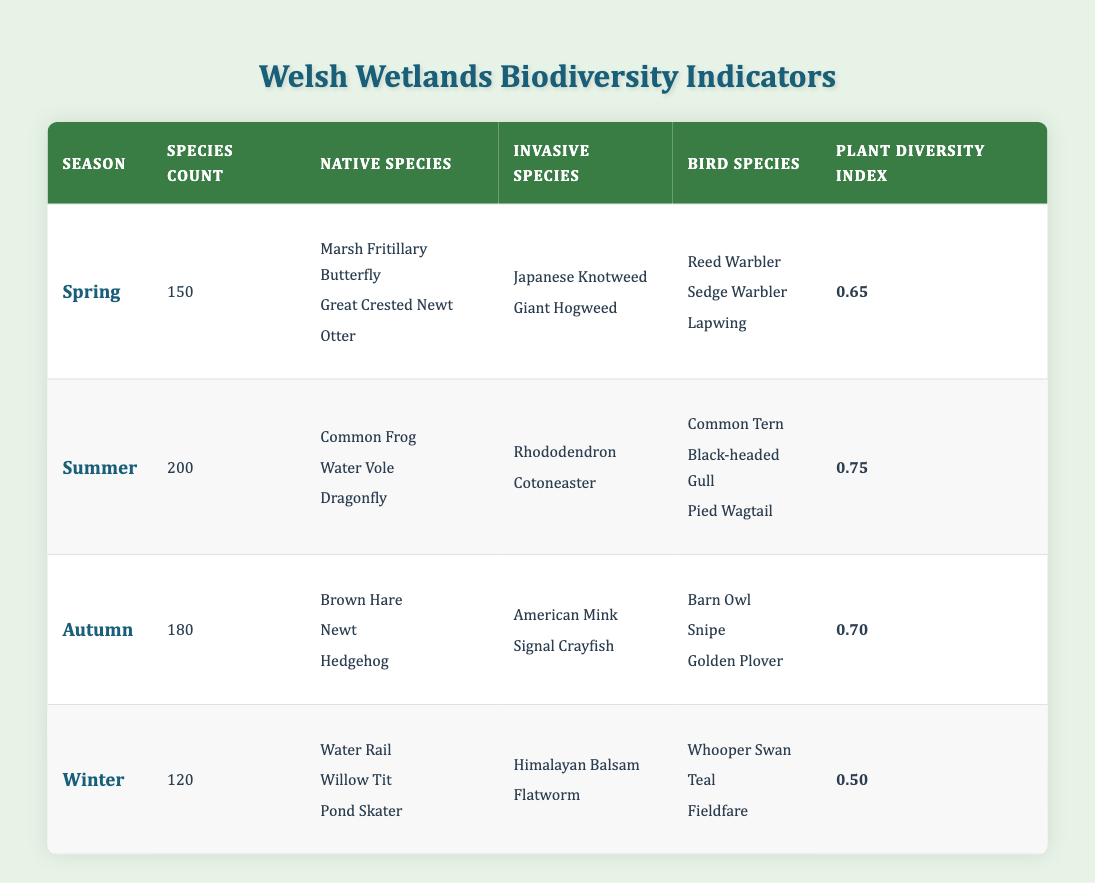What is the species count in Summer? The table directly states the species count for Summer is 200.
Answer: 200 Which Native Species are found in Autumn? The table lists three native species in Autumn: Brown Hare, Newt, and Hedgehog.
Answer: Brown Hare, Newt, Hedgehog Is the Plant Diversity Index higher in Spring or Winter? The Plant Diversity Index for Spring is 0.65, while for Winter, it is 0.50. Since 0.65 is greater than 0.50, it is higher in Spring.
Answer: Yes What is the total number of Species Count across all seasons? To find the total species count, we sum the counts for each season: 150 (Spring) + 200 (Summer) + 180 (Autumn) + 120 (Winter) = 650.
Answer: 650 How many Invasive Species are there in Winter? The table shows that in Winter, there are two invasive species: Himalayan Balsam and Flatworm.
Answer: 2 What is the average Plant Diversity Index for all seasons? The Plant Diversity Index values are 0.65 (Spring), 0.75 (Summer), 0.70 (Autumn), and 0.50 (Winter). To calculate the average, sum these values: 0.65 + 0.75 + 0.70 + 0.50 = 2.60, and divide by the number of seasons (4): 2.60 / 4 = 0.65.
Answer: 0.65 Which season has the highest number of Bird Species? The table lists the number of bird species for each season: Spring has 3, Summer has 3, Autumn has 3, and Winter has 3. All seasons have the same number of bird species, which is 3.
Answer: No Are there any invasive species in Spring? The table indicates that Spring has invasive species: Japanese Knotweed and Giant Hogweed. Therefore, there are invasive species in Spring.
Answer: Yes Which Native Species appears in both Spring and Summer? From the lists of native species, there is no overlap between the native species in Spring (Marsh Fritillary Butterfly, Great Crested Newt, Otter) and Summer (Common Frog, Water Vole, Dragonfly). Therefore, no native species appears in both seasons.
Answer: No 